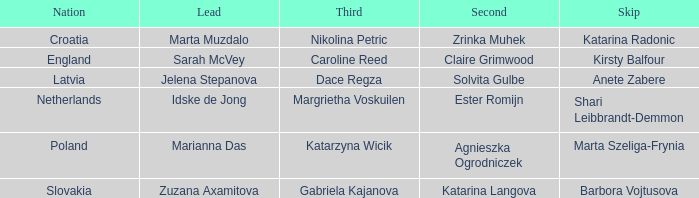What is the name of the second who has Caroline Reed as third? Claire Grimwood. 